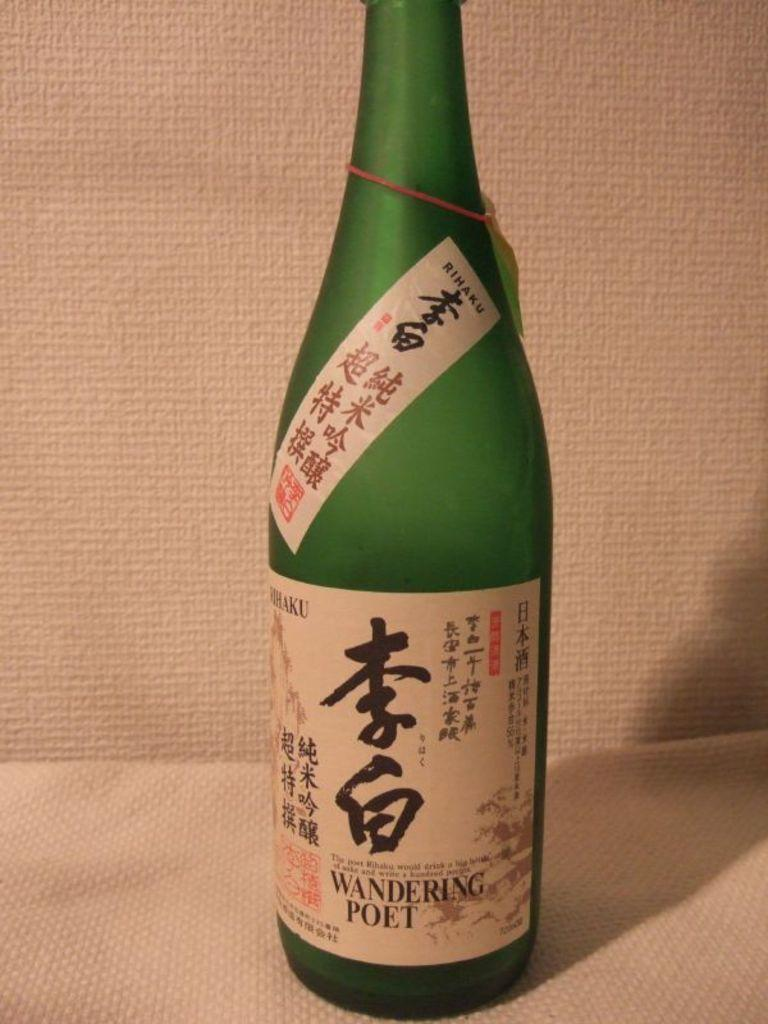<image>
Render a clear and concise summary of the photo. A bottle of a drink called Wandering Poet. 